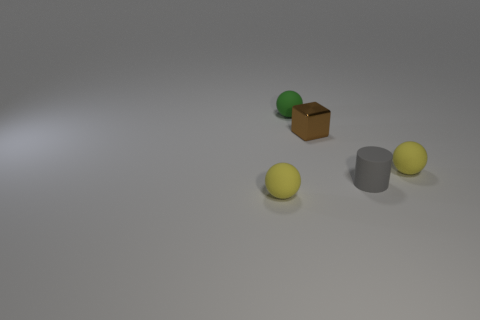Are there any other things that are made of the same material as the brown thing?
Offer a very short reply. No. There is a small yellow thing that is on the right side of the tiny yellow thing left of the brown cube; are there any tiny matte balls that are behind it?
Give a very brief answer. Yes. Are there fewer gray rubber things than purple matte blocks?
Offer a terse response. No. There is a small yellow rubber thing that is on the right side of the green rubber ball; does it have the same shape as the small green thing?
Provide a short and direct response. Yes. Is there a large green thing?
Your response must be concise. No. There is a tiny block that is behind the rubber sphere that is to the left of the small thing that is behind the small brown metal thing; what is its color?
Give a very brief answer. Brown. Is the number of brown metal blocks to the right of the brown object the same as the number of balls that are behind the gray matte object?
Ensure brevity in your answer.  No. What is the shape of the green thing that is the same size as the cube?
Ensure brevity in your answer.  Sphere. Is there a small matte cylinder that has the same color as the cube?
Offer a very short reply. No. There is a small object that is behind the brown thing; what shape is it?
Your response must be concise. Sphere. 